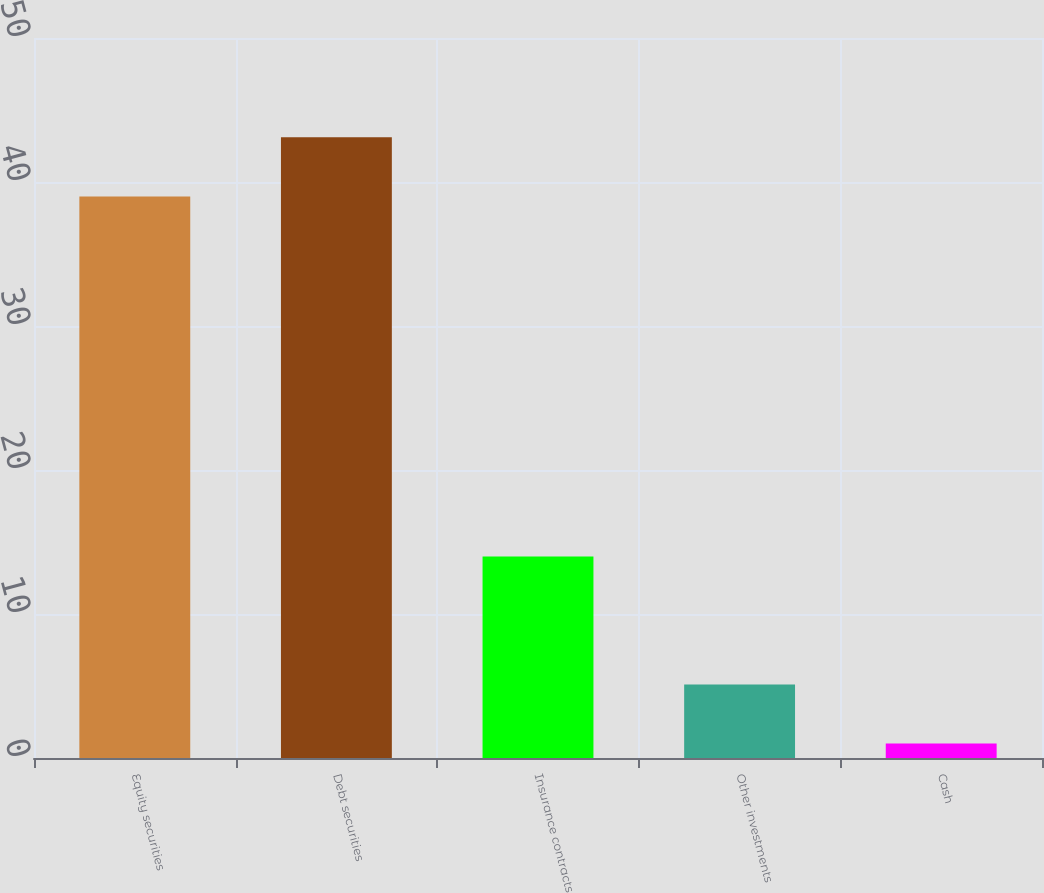<chart> <loc_0><loc_0><loc_500><loc_500><bar_chart><fcel>Equity securities<fcel>Debt securities<fcel>Insurance contracts<fcel>Other investments<fcel>Cash<nl><fcel>39<fcel>43.1<fcel>14<fcel>5.1<fcel>1<nl></chart> 